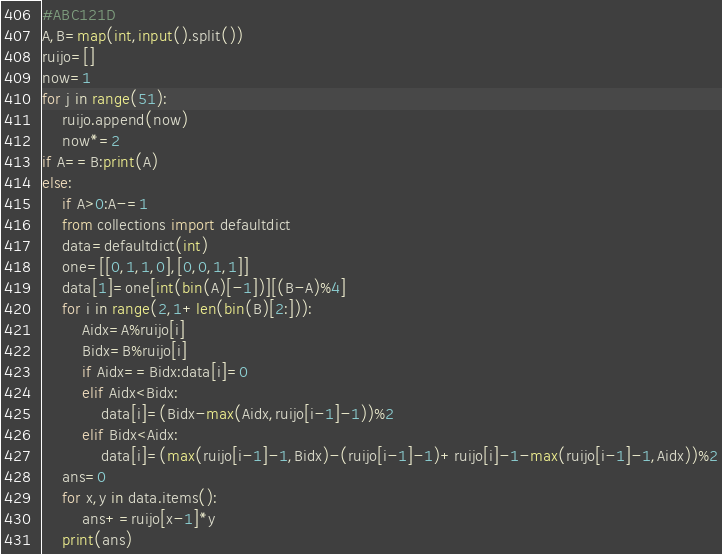Convert code to text. <code><loc_0><loc_0><loc_500><loc_500><_Python_>#ABC121D
A,B=map(int,input().split())
ruijo=[]
now=1
for j in range(51):
    ruijo.append(now)
    now*=2
if A==B:print(A)
else:
    if A>0:A-=1
    from collections import defaultdict
    data=defaultdict(int)
    one=[[0,1,1,0],[0,0,1,1]]
    data[1]=one[int(bin(A)[-1])][(B-A)%4]
    for i in range(2,1+len(bin(B)[2:])):
        Aidx=A%ruijo[i]
        Bidx=B%ruijo[i]
        if Aidx==Bidx:data[i]=0
        elif Aidx<Bidx:
            data[i]=(Bidx-max(Aidx,ruijo[i-1]-1))%2
        elif Bidx<Aidx:
            data[i]=(max(ruijo[i-1]-1,Bidx)-(ruijo[i-1]-1)+ruijo[i]-1-max(ruijo[i-1]-1,Aidx))%2
    ans=0
    for x,y in data.items():
        ans+=ruijo[x-1]*y
    print(ans)</code> 